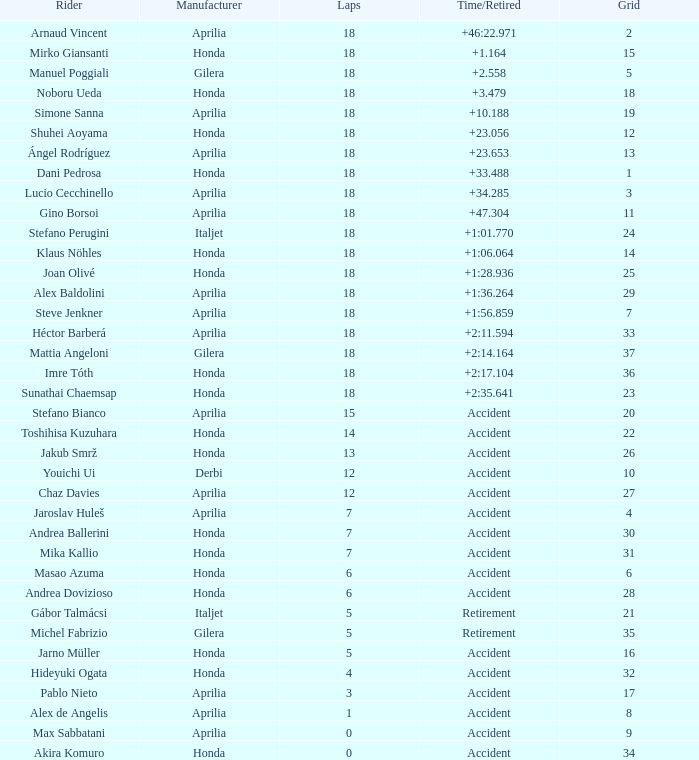Which competitor has less than 15 laps to their name, more than 32 grid entries, and an incident causing them to retire? Akira Komuro. 